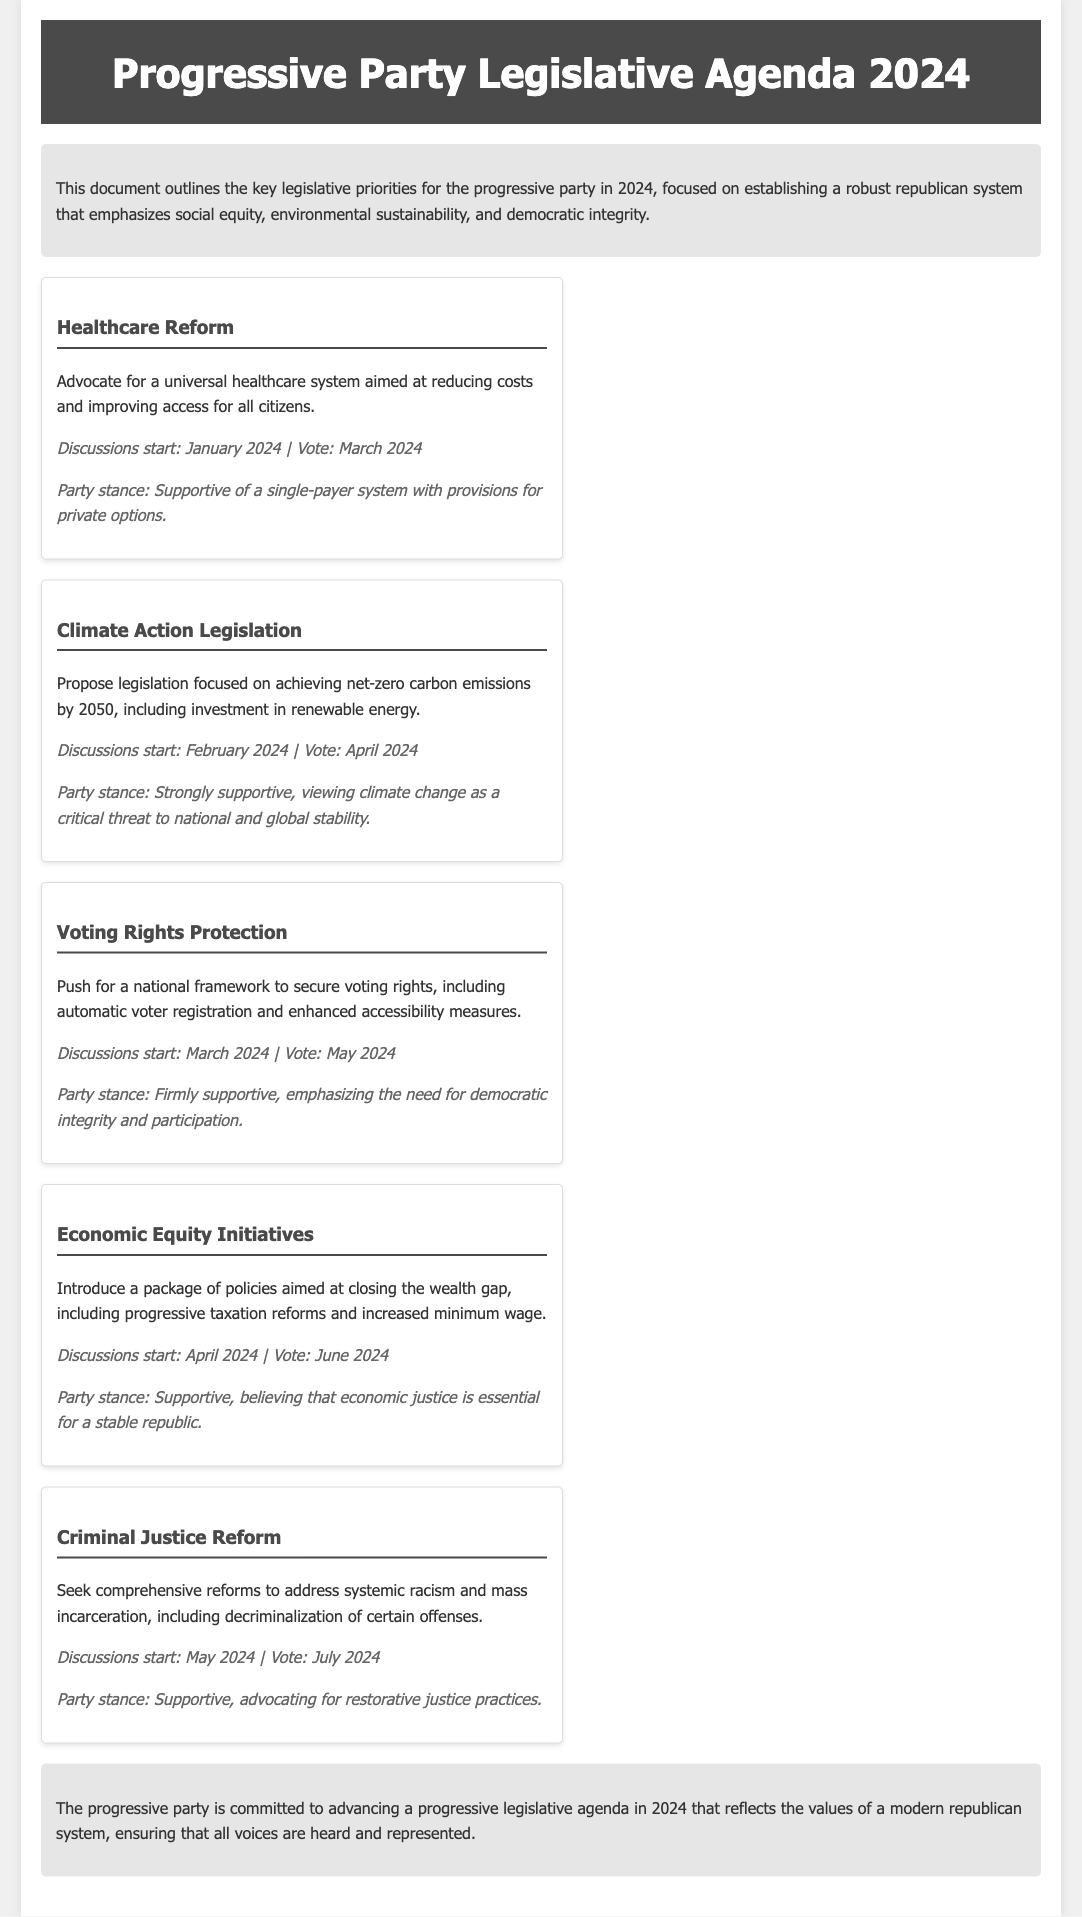What is the first issue discussed in the legislative agenda? The first issue listed in the document is Healthcare Reform as it appears first in the list of key issues.
Answer: Healthcare Reform When does the discussion for Voting Rights Protection start? The timeline for discussions for Voting Rights Protection is outlined in the document, stating when discussions will begin.
Answer: March 2024 What is the party’s stance on Climate Action Legislation? The document outlines the party's position on each legislative proposal, including Climate Action Legislation.
Answer: Strongly supportive In what month is the vote for Economic Equity Initiatives scheduled? The document specifies the voting schedule for Economic Equity Initiatives, indicating when the vote will take place.
Answer: June 2024 What is the overarching goal of the healthcare reform proposal? The document provides a brief description of the healthcare reform proposal, highlighting its main objectives.
Answer: Universal healthcare system What issue is scheduled for discussion in April 2024? The timeline indicates which issues will be discussed in which months, detailing the order of discussions.
Answer: Economic Equity Initiatives What significant change is proposed under Criminal Justice Reform? The document summarizes the key aspects of Criminal Justice Reform, including the main reforms being advocated.
Answer: Decriminalization of certain offenses What is the start date for discussions on Climate Action Legislation? The timeline provides specific dates for starting discussions on the legislative proposals.
Answer: February 2024 